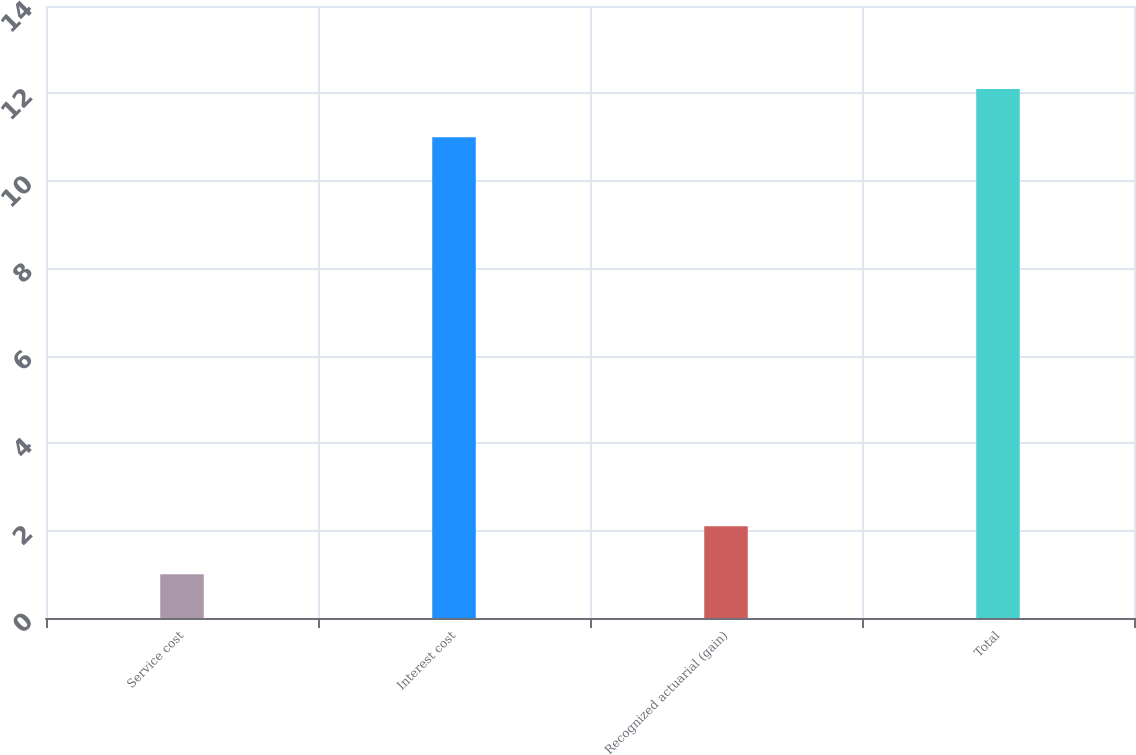Convert chart. <chart><loc_0><loc_0><loc_500><loc_500><bar_chart><fcel>Service cost<fcel>Interest cost<fcel>Recognized actuarial (gain)<fcel>Total<nl><fcel>1<fcel>11<fcel>2.1<fcel>12.1<nl></chart> 